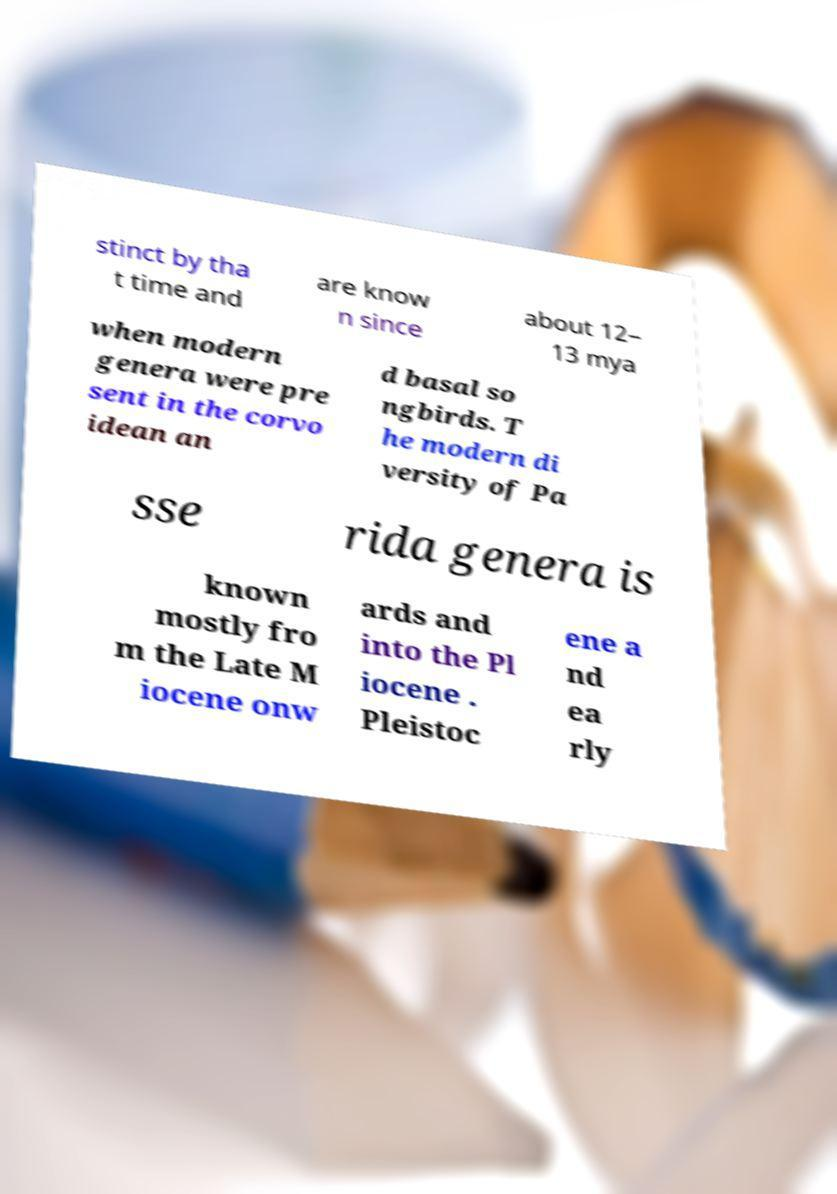Could you extract and type out the text from this image? stinct by tha t time and are know n since about 12– 13 mya when modern genera were pre sent in the corvo idean an d basal so ngbirds. T he modern di versity of Pa sse rida genera is known mostly fro m the Late M iocene onw ards and into the Pl iocene . Pleistoc ene a nd ea rly 